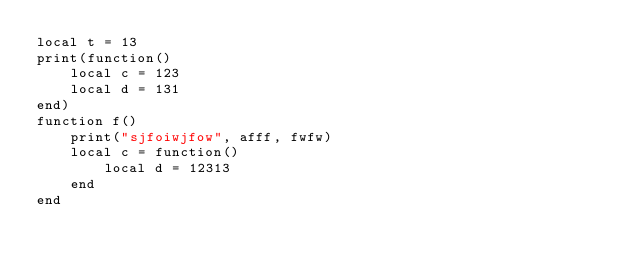<code> <loc_0><loc_0><loc_500><loc_500><_Lua_>local t = 13
print(function()
    local c = 123
    local d = 131
end)
function f()
    print("sjfoiwjfow", afff, fwfw)
    local c = function()
        local d = 12313
    end
end
</code> 